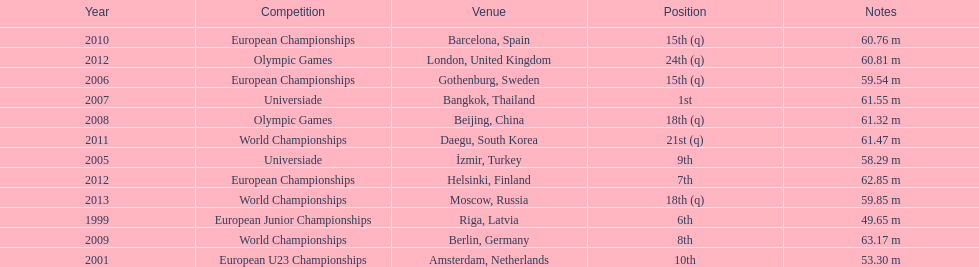What was the last competition he was in before the 2012 olympics? European Championships. Would you mind parsing the complete table? {'header': ['Year', 'Competition', 'Venue', 'Position', 'Notes'], 'rows': [['2010', 'European Championships', 'Barcelona, Spain', '15th (q)', '60.76 m'], ['2012', 'Olympic Games', 'London, United Kingdom', '24th (q)', '60.81 m'], ['2006', 'European Championships', 'Gothenburg, Sweden', '15th (q)', '59.54 m'], ['2007', 'Universiade', 'Bangkok, Thailand', '1st', '61.55 m'], ['2008', 'Olympic Games', 'Beijing, China', '18th (q)', '61.32 m'], ['2011', 'World Championships', 'Daegu, South Korea', '21st (q)', '61.47 m'], ['2005', 'Universiade', 'İzmir, Turkey', '9th', '58.29 m'], ['2012', 'European Championships', 'Helsinki, Finland', '7th', '62.85 m'], ['2013', 'World Championships', 'Moscow, Russia', '18th (q)', '59.85 m'], ['1999', 'European Junior Championships', 'Riga, Latvia', '6th', '49.65 m'], ['2009', 'World Championships', 'Berlin, Germany', '8th', '63.17 m'], ['2001', 'European U23 Championships', 'Amsterdam, Netherlands', '10th', '53.30 m']]} 